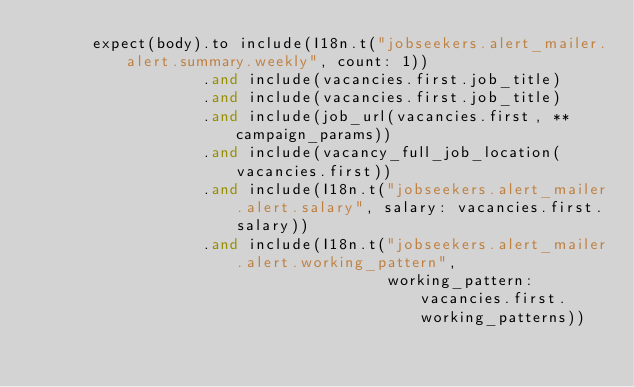Convert code to text. <code><loc_0><loc_0><loc_500><loc_500><_Ruby_>      expect(body).to include(I18n.t("jobseekers.alert_mailer.alert.summary.weekly", count: 1))
                  .and include(vacancies.first.job_title)
                  .and include(vacancies.first.job_title)
                  .and include(job_url(vacancies.first, **campaign_params))
                  .and include(vacancy_full_job_location(vacancies.first))
                  .and include(I18n.t("jobseekers.alert_mailer.alert.salary", salary: vacancies.first.salary))
                  .and include(I18n.t("jobseekers.alert_mailer.alert.working_pattern",
                                      working_pattern: vacancies.first.working_patterns))</code> 